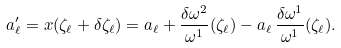Convert formula to latex. <formula><loc_0><loc_0><loc_500><loc_500>a ^ { \prime } _ { \ell } = x ( \zeta _ { \ell } + \delta \zeta _ { \ell } ) = a _ { \ell } + \frac { \delta \omega ^ { 2 } } { \omega ^ { 1 } } ( \zeta _ { \ell } ) - a _ { \ell } \, \frac { \delta \omega ^ { 1 } } { \omega ^ { 1 } } ( \zeta _ { \ell } ) .</formula> 